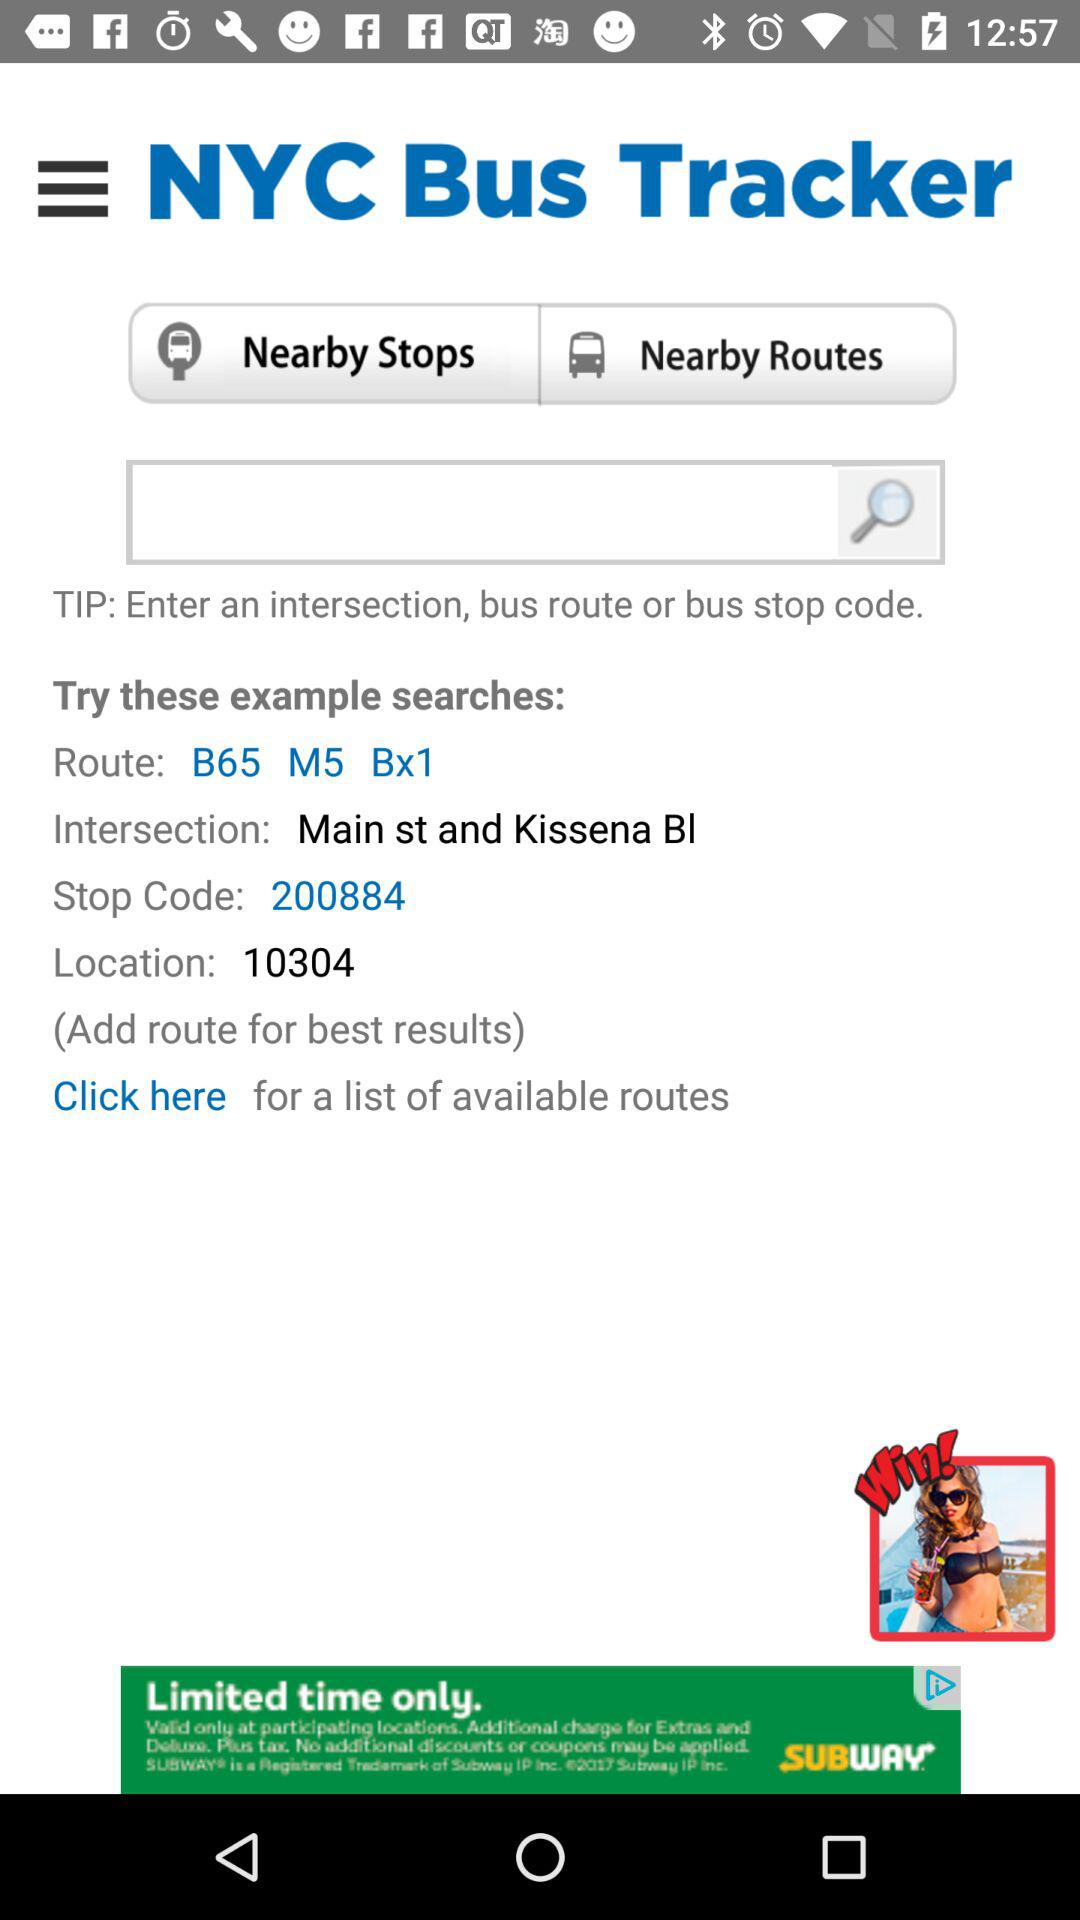What is the application name? The application name is "NYC Bus Tracker". 